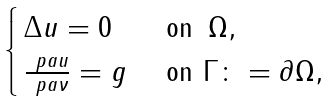Convert formula to latex. <formula><loc_0><loc_0><loc_500><loc_500>\begin{cases} \, \Delta u = 0 & \text { on } \, \Omega , \\ \, \frac { \ p a u } { \ p a \nu } = g & \text { on } \Gamma \colon = \partial \Omega , \end{cases}</formula> 